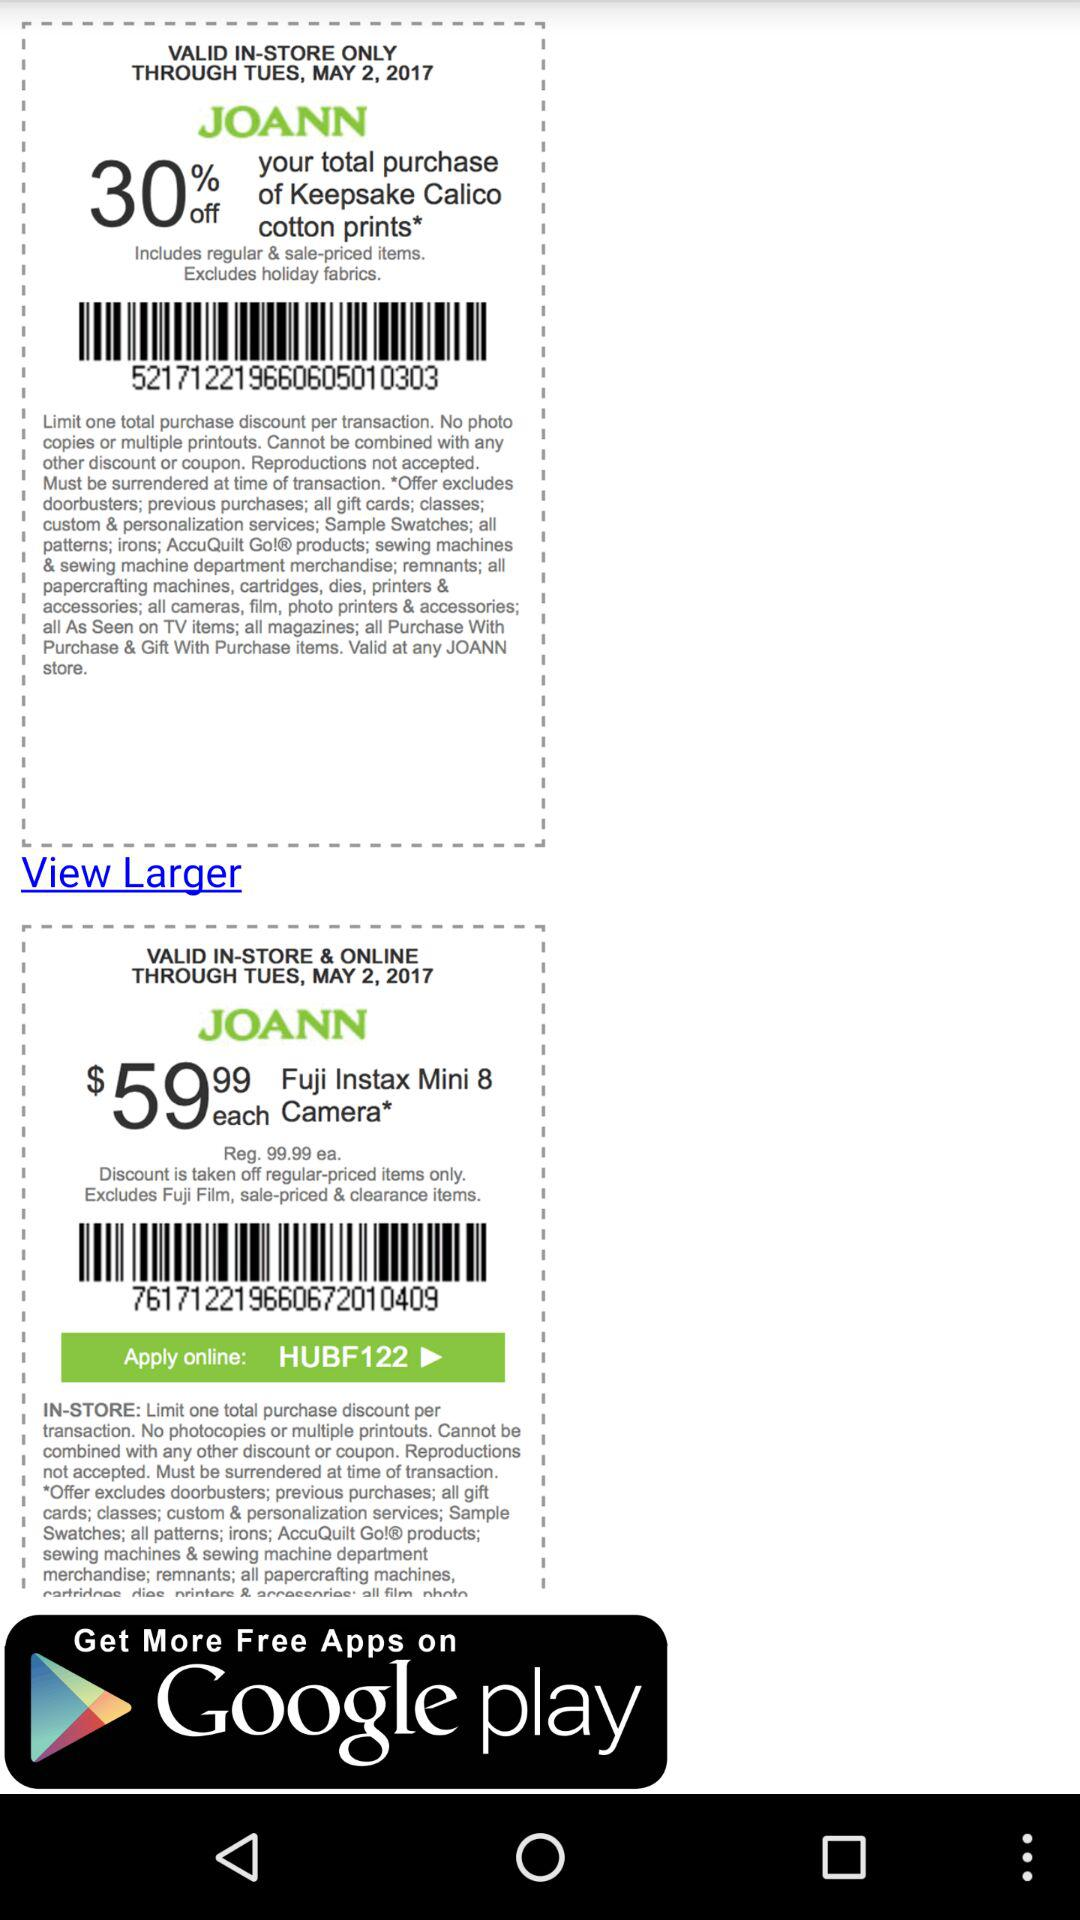What is the price of the "Fuji Instax Mini 8 Camera"? The price of the "Fuji Instax Mini 8 Camera" is $59.99. 